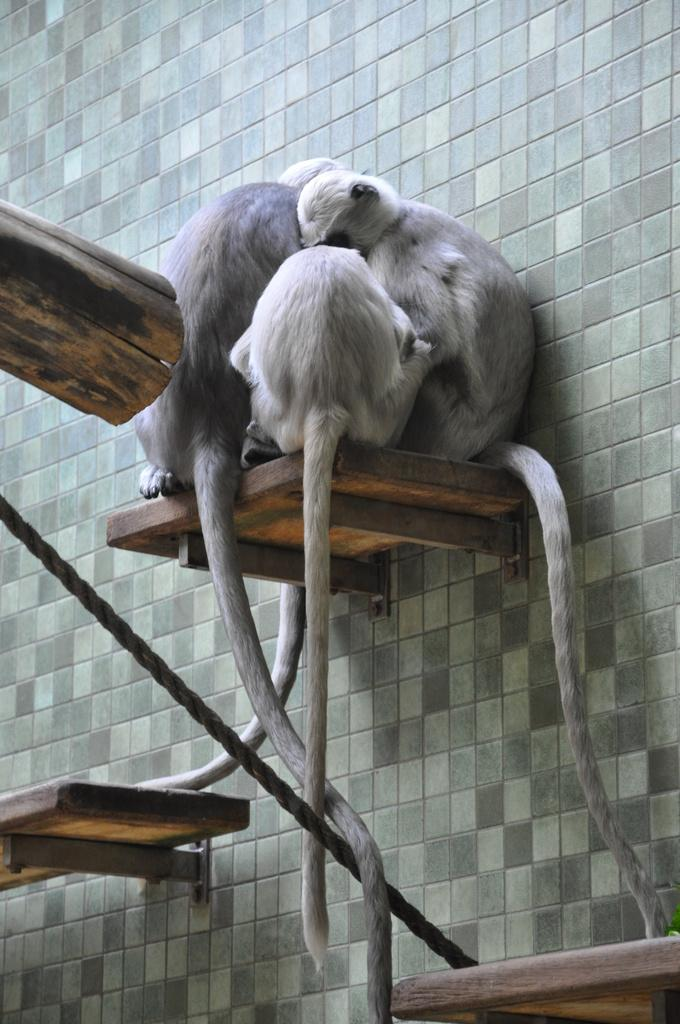What animals are in the center of the image? There are small monkeys in the center of the image. What are the monkeys standing on? The monkeys are on a wooden board. Are there any other wooden boards visible in the image? Yes, there are wooden boards at the bottom side of the image. What type of advertisement can be seen on the wooden board in the image? There is no advertisement present on the wooden board in the image; it only features small monkeys. 